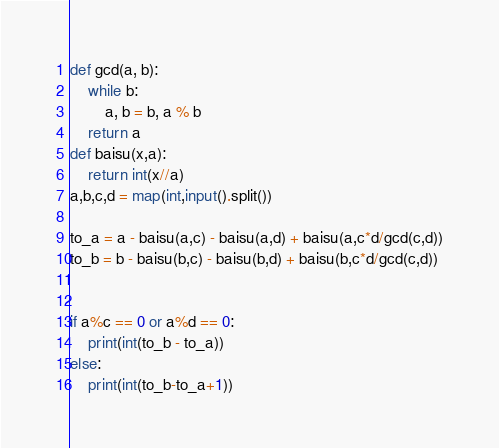Convert code to text. <code><loc_0><loc_0><loc_500><loc_500><_Python_>def gcd(a, b):
	while b:
		a, b = b, a % b
	return a
def baisu(x,a):
    return int(x//a)
a,b,c,d = map(int,input().split())

to_a = a - baisu(a,c) - baisu(a,d) + baisu(a,c*d/gcd(c,d))
to_b = b - baisu(b,c) - baisu(b,d) + baisu(b,c*d/gcd(c,d))


if a%c == 0 or a%d == 0:
    print(int(to_b - to_a))
else:
    print(int(to_b-to_a+1))</code> 